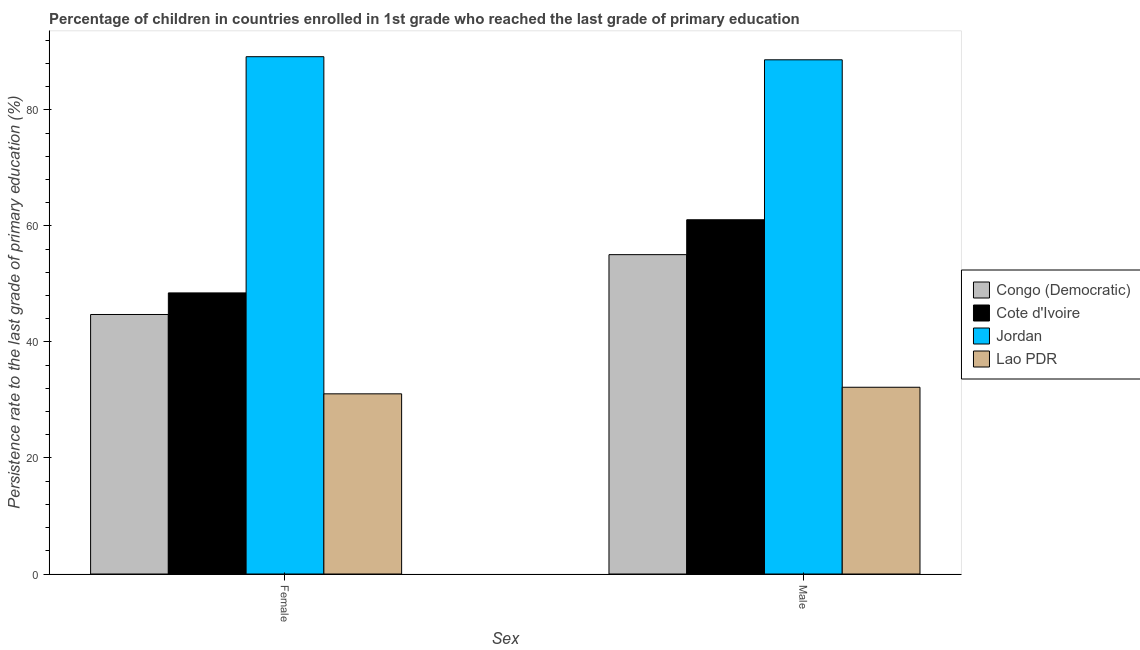How many groups of bars are there?
Give a very brief answer. 2. Are the number of bars on each tick of the X-axis equal?
Offer a very short reply. Yes. How many bars are there on the 2nd tick from the right?
Offer a terse response. 4. What is the persistence rate of male students in Lao PDR?
Your answer should be very brief. 32.19. Across all countries, what is the maximum persistence rate of male students?
Ensure brevity in your answer.  88.64. Across all countries, what is the minimum persistence rate of male students?
Your answer should be very brief. 32.19. In which country was the persistence rate of male students maximum?
Your answer should be very brief. Jordan. In which country was the persistence rate of female students minimum?
Your answer should be compact. Lao PDR. What is the total persistence rate of female students in the graph?
Your answer should be very brief. 213.42. What is the difference between the persistence rate of female students in Congo (Democratic) and that in Cote d'Ivoire?
Ensure brevity in your answer.  -3.72. What is the difference between the persistence rate of female students in Lao PDR and the persistence rate of male students in Congo (Democratic)?
Offer a terse response. -23.99. What is the average persistence rate of female students per country?
Ensure brevity in your answer.  53.36. What is the difference between the persistence rate of female students and persistence rate of male students in Cote d'Ivoire?
Your answer should be compact. -12.61. What is the ratio of the persistence rate of female students in Cote d'Ivoire to that in Lao PDR?
Offer a very short reply. 1.56. What does the 4th bar from the left in Male represents?
Give a very brief answer. Lao PDR. What does the 1st bar from the right in Female represents?
Offer a very short reply. Lao PDR. How many bars are there?
Offer a terse response. 8. Where does the legend appear in the graph?
Offer a terse response. Center right. What is the title of the graph?
Give a very brief answer. Percentage of children in countries enrolled in 1st grade who reached the last grade of primary education. What is the label or title of the X-axis?
Keep it short and to the point. Sex. What is the label or title of the Y-axis?
Give a very brief answer. Persistence rate to the last grade of primary education (%). What is the Persistence rate to the last grade of primary education (%) in Congo (Democratic) in Female?
Your response must be concise. 44.74. What is the Persistence rate to the last grade of primary education (%) in Cote d'Ivoire in Female?
Your answer should be compact. 48.45. What is the Persistence rate to the last grade of primary education (%) in Jordan in Female?
Your response must be concise. 89.17. What is the Persistence rate to the last grade of primary education (%) in Lao PDR in Female?
Your answer should be very brief. 31.06. What is the Persistence rate to the last grade of primary education (%) in Congo (Democratic) in Male?
Make the answer very short. 55.05. What is the Persistence rate to the last grade of primary education (%) of Cote d'Ivoire in Male?
Provide a short and direct response. 61.06. What is the Persistence rate to the last grade of primary education (%) in Jordan in Male?
Offer a very short reply. 88.64. What is the Persistence rate to the last grade of primary education (%) of Lao PDR in Male?
Your answer should be very brief. 32.19. Across all Sex, what is the maximum Persistence rate to the last grade of primary education (%) in Congo (Democratic)?
Provide a short and direct response. 55.05. Across all Sex, what is the maximum Persistence rate to the last grade of primary education (%) in Cote d'Ivoire?
Ensure brevity in your answer.  61.06. Across all Sex, what is the maximum Persistence rate to the last grade of primary education (%) in Jordan?
Provide a short and direct response. 89.17. Across all Sex, what is the maximum Persistence rate to the last grade of primary education (%) of Lao PDR?
Your response must be concise. 32.19. Across all Sex, what is the minimum Persistence rate to the last grade of primary education (%) in Congo (Democratic)?
Your answer should be compact. 44.74. Across all Sex, what is the minimum Persistence rate to the last grade of primary education (%) in Cote d'Ivoire?
Provide a short and direct response. 48.45. Across all Sex, what is the minimum Persistence rate to the last grade of primary education (%) of Jordan?
Your response must be concise. 88.64. Across all Sex, what is the minimum Persistence rate to the last grade of primary education (%) in Lao PDR?
Offer a terse response. 31.06. What is the total Persistence rate to the last grade of primary education (%) in Congo (Democratic) in the graph?
Give a very brief answer. 99.79. What is the total Persistence rate to the last grade of primary education (%) in Cote d'Ivoire in the graph?
Offer a very short reply. 109.52. What is the total Persistence rate to the last grade of primary education (%) in Jordan in the graph?
Your answer should be compact. 177.81. What is the total Persistence rate to the last grade of primary education (%) of Lao PDR in the graph?
Offer a very short reply. 63.25. What is the difference between the Persistence rate to the last grade of primary education (%) in Congo (Democratic) in Female and that in Male?
Your answer should be very brief. -10.32. What is the difference between the Persistence rate to the last grade of primary education (%) in Cote d'Ivoire in Female and that in Male?
Give a very brief answer. -12.61. What is the difference between the Persistence rate to the last grade of primary education (%) of Jordan in Female and that in Male?
Make the answer very short. 0.54. What is the difference between the Persistence rate to the last grade of primary education (%) of Lao PDR in Female and that in Male?
Provide a succinct answer. -1.13. What is the difference between the Persistence rate to the last grade of primary education (%) in Congo (Democratic) in Female and the Persistence rate to the last grade of primary education (%) in Cote d'Ivoire in Male?
Your answer should be very brief. -16.33. What is the difference between the Persistence rate to the last grade of primary education (%) in Congo (Democratic) in Female and the Persistence rate to the last grade of primary education (%) in Jordan in Male?
Ensure brevity in your answer.  -43.9. What is the difference between the Persistence rate to the last grade of primary education (%) in Congo (Democratic) in Female and the Persistence rate to the last grade of primary education (%) in Lao PDR in Male?
Make the answer very short. 12.54. What is the difference between the Persistence rate to the last grade of primary education (%) in Cote d'Ivoire in Female and the Persistence rate to the last grade of primary education (%) in Jordan in Male?
Your answer should be very brief. -40.18. What is the difference between the Persistence rate to the last grade of primary education (%) of Cote d'Ivoire in Female and the Persistence rate to the last grade of primary education (%) of Lao PDR in Male?
Make the answer very short. 16.26. What is the difference between the Persistence rate to the last grade of primary education (%) of Jordan in Female and the Persistence rate to the last grade of primary education (%) of Lao PDR in Male?
Provide a succinct answer. 56.98. What is the average Persistence rate to the last grade of primary education (%) in Congo (Democratic) per Sex?
Make the answer very short. 49.89. What is the average Persistence rate to the last grade of primary education (%) in Cote d'Ivoire per Sex?
Ensure brevity in your answer.  54.76. What is the average Persistence rate to the last grade of primary education (%) in Jordan per Sex?
Offer a terse response. 88.91. What is the average Persistence rate to the last grade of primary education (%) in Lao PDR per Sex?
Your answer should be compact. 31.62. What is the difference between the Persistence rate to the last grade of primary education (%) of Congo (Democratic) and Persistence rate to the last grade of primary education (%) of Cote d'Ivoire in Female?
Give a very brief answer. -3.72. What is the difference between the Persistence rate to the last grade of primary education (%) in Congo (Democratic) and Persistence rate to the last grade of primary education (%) in Jordan in Female?
Offer a very short reply. -44.44. What is the difference between the Persistence rate to the last grade of primary education (%) of Congo (Democratic) and Persistence rate to the last grade of primary education (%) of Lao PDR in Female?
Your answer should be compact. 13.68. What is the difference between the Persistence rate to the last grade of primary education (%) in Cote d'Ivoire and Persistence rate to the last grade of primary education (%) in Jordan in Female?
Offer a very short reply. -40.72. What is the difference between the Persistence rate to the last grade of primary education (%) of Cote d'Ivoire and Persistence rate to the last grade of primary education (%) of Lao PDR in Female?
Your answer should be very brief. 17.4. What is the difference between the Persistence rate to the last grade of primary education (%) of Jordan and Persistence rate to the last grade of primary education (%) of Lao PDR in Female?
Give a very brief answer. 58.12. What is the difference between the Persistence rate to the last grade of primary education (%) in Congo (Democratic) and Persistence rate to the last grade of primary education (%) in Cote d'Ivoire in Male?
Provide a short and direct response. -6.01. What is the difference between the Persistence rate to the last grade of primary education (%) of Congo (Democratic) and Persistence rate to the last grade of primary education (%) of Jordan in Male?
Offer a very short reply. -33.59. What is the difference between the Persistence rate to the last grade of primary education (%) in Congo (Democratic) and Persistence rate to the last grade of primary education (%) in Lao PDR in Male?
Ensure brevity in your answer.  22.86. What is the difference between the Persistence rate to the last grade of primary education (%) in Cote d'Ivoire and Persistence rate to the last grade of primary education (%) in Jordan in Male?
Your answer should be compact. -27.57. What is the difference between the Persistence rate to the last grade of primary education (%) of Cote d'Ivoire and Persistence rate to the last grade of primary education (%) of Lao PDR in Male?
Ensure brevity in your answer.  28.87. What is the difference between the Persistence rate to the last grade of primary education (%) in Jordan and Persistence rate to the last grade of primary education (%) in Lao PDR in Male?
Provide a short and direct response. 56.45. What is the ratio of the Persistence rate to the last grade of primary education (%) of Congo (Democratic) in Female to that in Male?
Offer a very short reply. 0.81. What is the ratio of the Persistence rate to the last grade of primary education (%) in Cote d'Ivoire in Female to that in Male?
Offer a terse response. 0.79. What is the ratio of the Persistence rate to the last grade of primary education (%) of Jordan in Female to that in Male?
Provide a short and direct response. 1.01. What is the ratio of the Persistence rate to the last grade of primary education (%) in Lao PDR in Female to that in Male?
Your answer should be very brief. 0.96. What is the difference between the highest and the second highest Persistence rate to the last grade of primary education (%) of Congo (Democratic)?
Offer a very short reply. 10.32. What is the difference between the highest and the second highest Persistence rate to the last grade of primary education (%) in Cote d'Ivoire?
Your answer should be compact. 12.61. What is the difference between the highest and the second highest Persistence rate to the last grade of primary education (%) of Jordan?
Keep it short and to the point. 0.54. What is the difference between the highest and the second highest Persistence rate to the last grade of primary education (%) of Lao PDR?
Your answer should be compact. 1.13. What is the difference between the highest and the lowest Persistence rate to the last grade of primary education (%) of Congo (Democratic)?
Make the answer very short. 10.32. What is the difference between the highest and the lowest Persistence rate to the last grade of primary education (%) of Cote d'Ivoire?
Offer a very short reply. 12.61. What is the difference between the highest and the lowest Persistence rate to the last grade of primary education (%) in Jordan?
Ensure brevity in your answer.  0.54. What is the difference between the highest and the lowest Persistence rate to the last grade of primary education (%) of Lao PDR?
Provide a succinct answer. 1.13. 